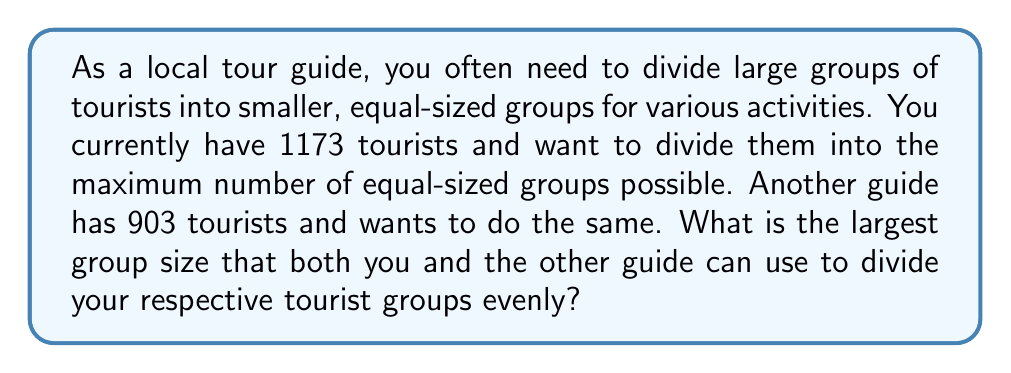Show me your answer to this math problem. To solve this problem, we need to find the greatest common divisor (GCD) of 1173 and 903. We can use the Euclidean algorithm:

1) First, set up the equation:
   $1173 = 1 \times 903 + 270$

2) Now, we continue the process with 903 and 270:
   $903 = 3 \times 270 + 93$

3) Continue with 270 and 93:
   $270 = 2 \times 93 + 84$

4) Continue with 93 and 84:
   $93 = 1 \times 84 + 9$

5) Continue with 84 and 9:
   $84 = 9 \times 9 + 3$

6) Continue with 9 and 3:
   $9 = 3 \times 3 + 0$

7) The process stops when we get a remainder of 0. The last non-zero remainder is the GCD.

Therefore, the GCD of 1173 and 903 is 3. This means that the largest group size that can evenly divide both 1173 and 903 is 3.

We can verify:
$1173 \div 3 = 391$ (no remainder)
$903 \div 3 = 301$ (no remainder)
Answer: 3 